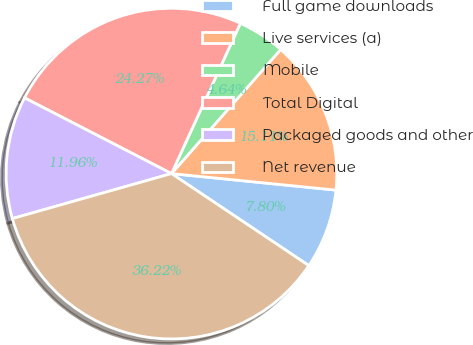Convert chart. <chart><loc_0><loc_0><loc_500><loc_500><pie_chart><fcel>Full game downloads<fcel>Live services (a)<fcel>Mobile<fcel>Total Digital<fcel>Packaged goods and other<fcel>Net revenue<nl><fcel>7.8%<fcel>15.11%<fcel>4.64%<fcel>24.27%<fcel>11.96%<fcel>36.22%<nl></chart> 